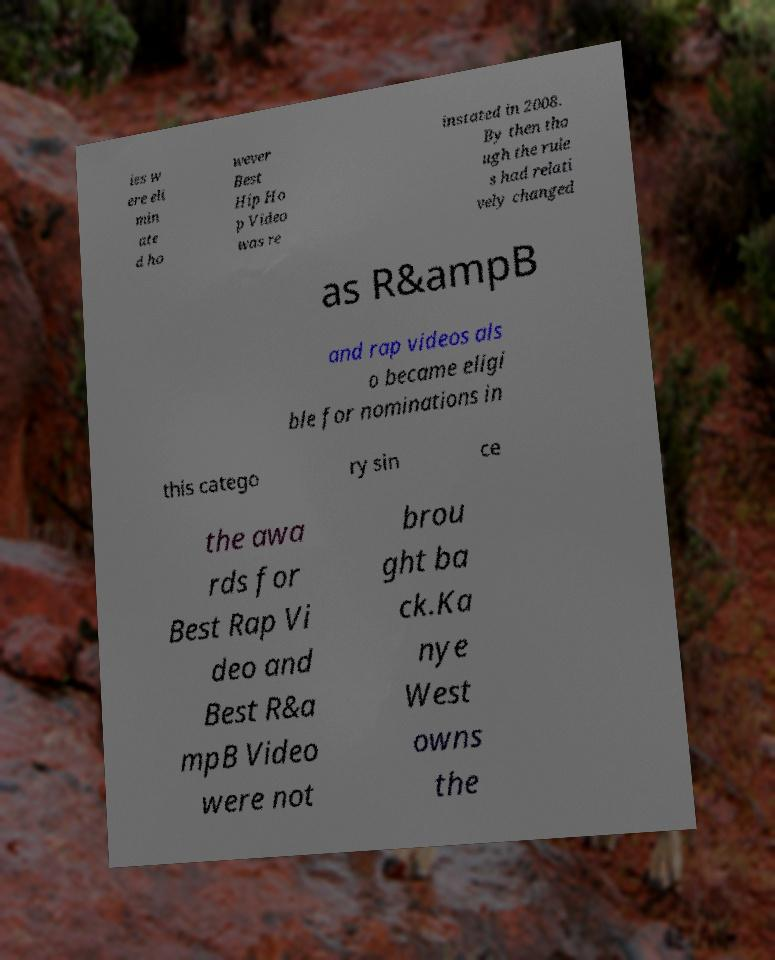I need the written content from this picture converted into text. Can you do that? ies w ere eli min ate d ho wever Best Hip Ho p Video was re instated in 2008. By then tho ugh the rule s had relati vely changed as R&ampB and rap videos als o became eligi ble for nominations in this catego ry sin ce the awa rds for Best Rap Vi deo and Best R&a mpB Video were not brou ght ba ck.Ka nye West owns the 